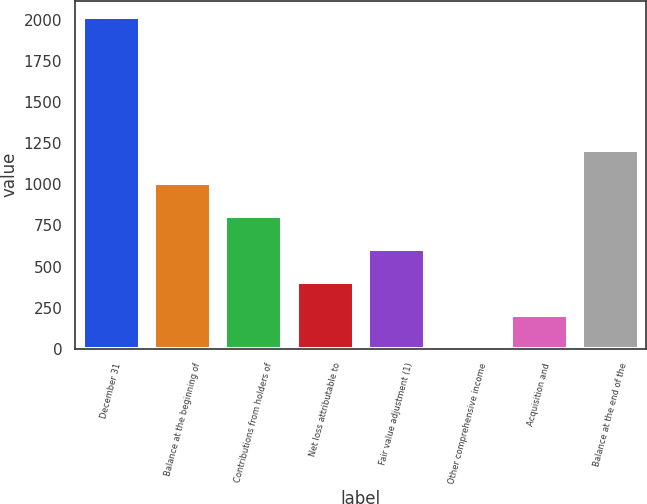Convert chart to OTSL. <chart><loc_0><loc_0><loc_500><loc_500><bar_chart><fcel>December 31<fcel>Balance at the beginning of<fcel>Contributions from holders of<fcel>Net loss attributable to<fcel>Fair value adjustment (1)<fcel>Other comprehensive income<fcel>Acquisition and<fcel>Balance at the end of the<nl><fcel>2017<fcel>1009.5<fcel>808<fcel>405<fcel>606.5<fcel>2<fcel>203.5<fcel>1211<nl></chart> 